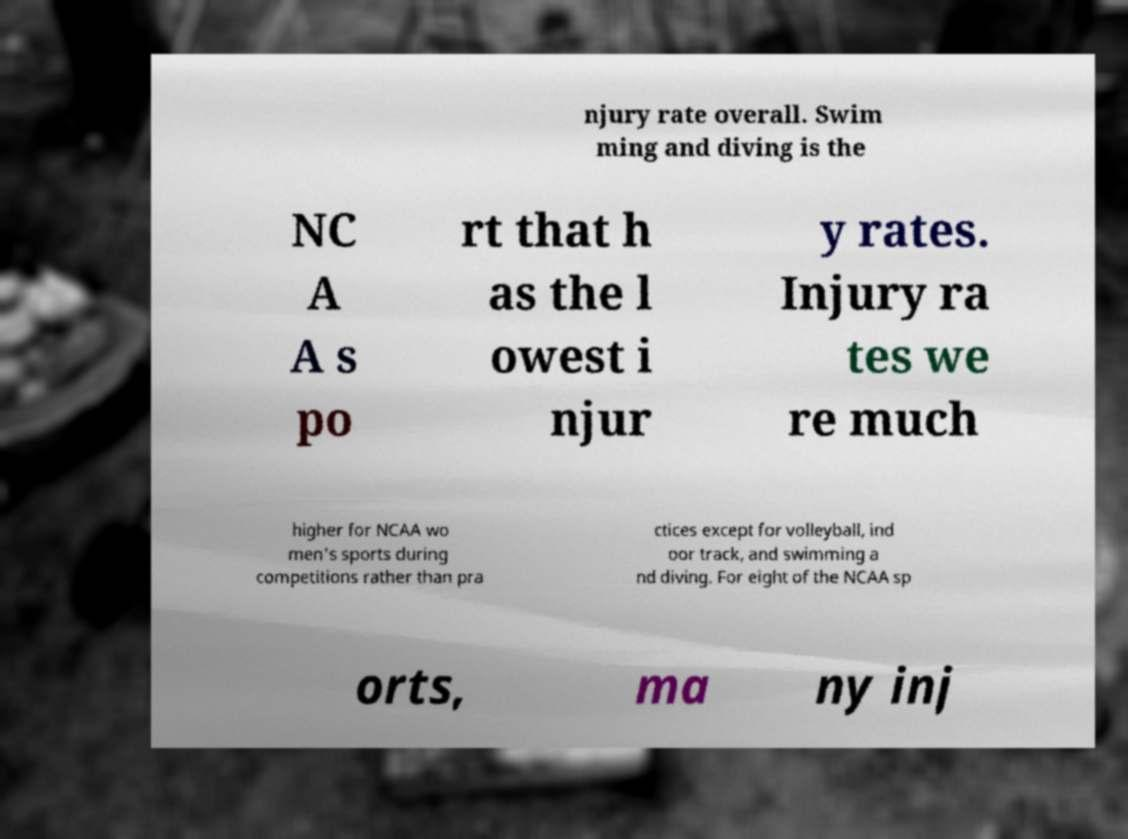Please identify and transcribe the text found in this image. njury rate overall. Swim ming and diving is the NC A A s po rt that h as the l owest i njur y rates. Injury ra tes we re much higher for NCAA wo men's sports during competitions rather than pra ctices except for volleyball, ind oor track, and swimming a nd diving. For eight of the NCAA sp orts, ma ny inj 